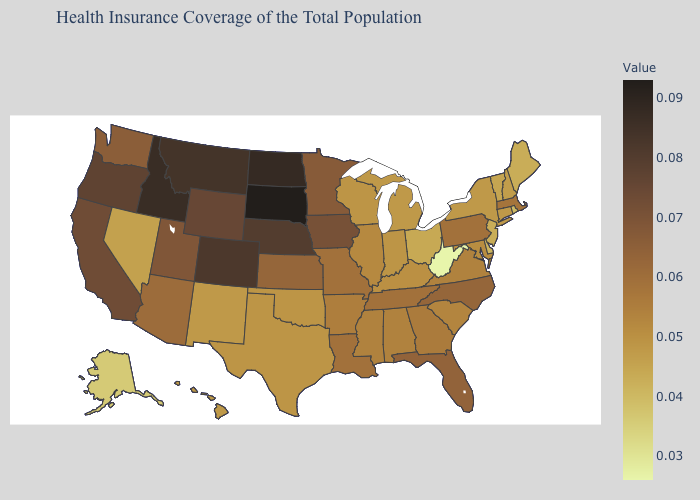Which states have the lowest value in the South?
Keep it brief. West Virginia. Among the states that border North Carolina , which have the highest value?
Write a very short answer. Tennessee. Which states have the lowest value in the USA?
Short answer required. West Virginia. Does Kentucky have a higher value than Louisiana?
Give a very brief answer. No. Which states have the lowest value in the USA?
Answer briefly. West Virginia. 